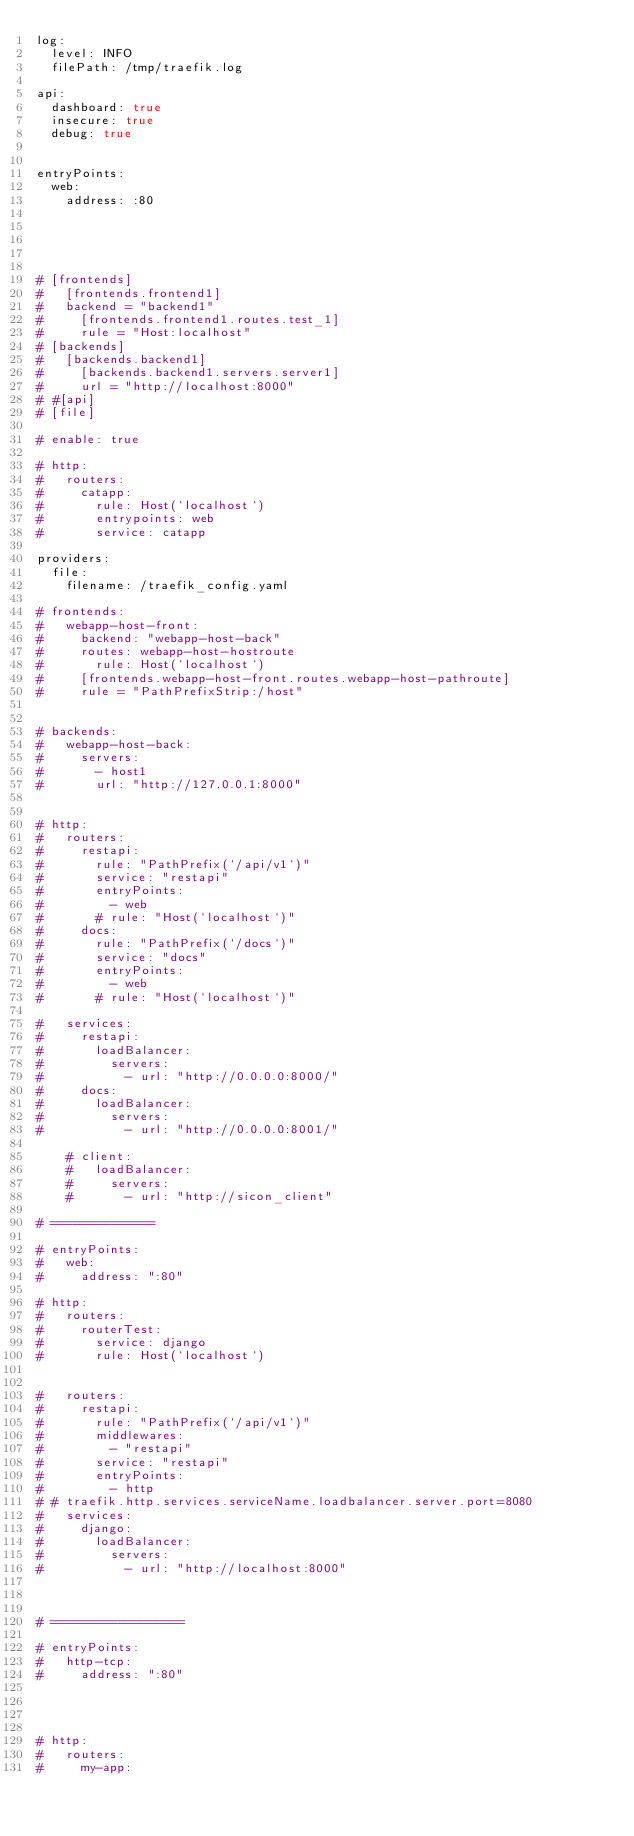<code> <loc_0><loc_0><loc_500><loc_500><_YAML_>log:
  level: INFO
  filePath: /tmp/traefik.log

api:
  dashboard: true
  insecure: true
  debug: true


entryPoints:
  web:
    address: :80





# [frontends]
#   [frontends.frontend1]
#   backend = "backend1"
#     [frontends.frontend1.routes.test_1]
#     rule = "Host:localhost"
# [backends]
#   [backends.backend1]
#     [backends.backend1.servers.server1]
#     url = "http://localhost:8000"
# #[api]
# [file]

# enable: true

# http:
#   routers:
#     catapp:
#       rule: Host(`localhost`)
#       entrypoints: web
#       service: catapp

providers:
  file:
    filename: /traefik_config.yaml

# frontends:
#   webapp-host-front:
#     backend: "webapp-host-back"
#     routes: webapp-host-hostroute
#       rule: Host(`localhost`)
#     [frontends.webapp-host-front.routes.webapp-host-pathroute]
#     rule = "PathPrefixStrip:/host"


# backends:
#   webapp-host-back:
#     servers:
#       - host1
#       url: "http://127.0.0.1:8000"


# http:
#   routers:
#     restapi:
#       rule: "PathPrefix(`/api/v1`)"
#       service: "restapi"
#       entryPoints:
#         - web
#       # rule: "Host(`localhost`)"
#     docs:
#       rule: "PathPrefix(`/docs`)"
#       service: "docs"
#       entryPoints:
#         - web
#       # rule: "Host(`localhost`)"

#   services:
#     restapi:
#       loadBalancer:
#         servers:
#           - url: "http://0.0.0.0:8000/"
#     docs:
#       loadBalancer:
#         servers:
#           - url: "http://0.0.0.0:8001/"

    # client:
    #   loadBalancer:
    #     servers:
    #       - url: "http://sicon_client"

# ==============

# entryPoints:
#   web:
#     address: ":80"

# http:
#   routers:
#     routerTest:
#       service: django
#       rule: Host(`localhost`)


#   routers:
#     restapi:
#       rule: "PathPrefix(`/api/v1`)"
#       middlewares:
#         - "restapi"
#       service: "restapi"
#       entryPoints:
#         - http
# # traefik.http.services.serviceName.loadbalancer.server.port=8080
#   services:
#     django:
#       loadBalancer:
#         servers:
#           - url: "http://localhost:8000"



# ==================

# entryPoints:
#   http-tcp:
#     address: ":80"




# http:
#   routers:
#     my-app:</code> 